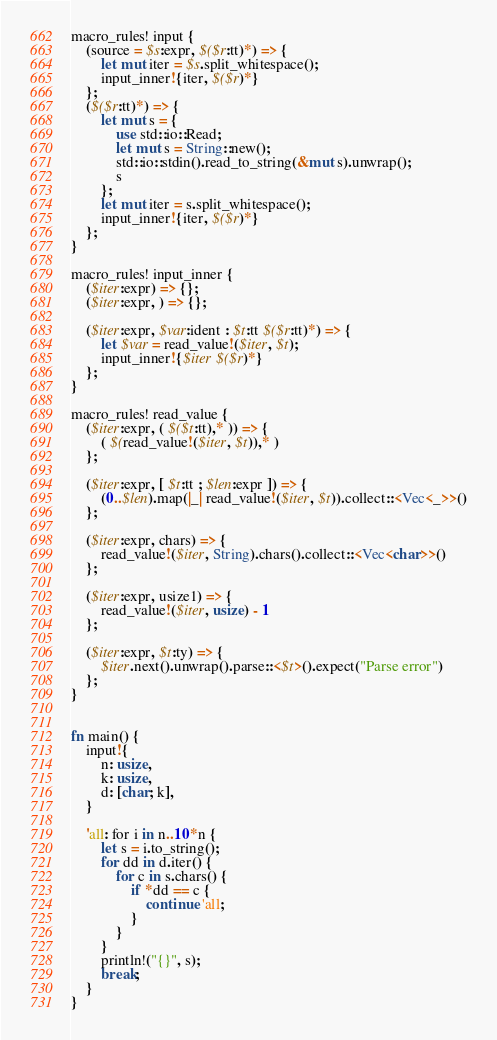Convert code to text. <code><loc_0><loc_0><loc_500><loc_500><_Rust_>macro_rules! input {
    (source = $s:expr, $($r:tt)*) => {
        let mut iter = $s.split_whitespace();
        input_inner!{iter, $($r)*}
    };
    ($($r:tt)*) => {
        let mut s = {
            use std::io::Read;
            let mut s = String::new();
            std::io::stdin().read_to_string(&mut s).unwrap();
            s
        };
        let mut iter = s.split_whitespace();
        input_inner!{iter, $($r)*}
    };
}

macro_rules! input_inner {
    ($iter:expr) => {};
    ($iter:expr, ) => {};

    ($iter:expr, $var:ident : $t:tt $($r:tt)*) => {
        let $var = read_value!($iter, $t);
        input_inner!{$iter $($r)*}
    };
}

macro_rules! read_value {
    ($iter:expr, ( $($t:tt),* )) => {
        ( $(read_value!($iter, $t)),* )
    };

    ($iter:expr, [ $t:tt ; $len:expr ]) => {
        (0..$len).map(|_| read_value!($iter, $t)).collect::<Vec<_>>()
    };

    ($iter:expr, chars) => {
        read_value!($iter, String).chars().collect::<Vec<char>>()
    };

    ($iter:expr, usize1) => {
        read_value!($iter, usize) - 1
    };

    ($iter:expr, $t:ty) => {
        $iter.next().unwrap().parse::<$t>().expect("Parse error")
    };
}


fn main() {
    input!{
        n: usize,
        k: usize,
        d: [char; k],
    }

    'all: for i in n..10*n {
        let s = i.to_string();
        for dd in d.iter() {
            for c in s.chars() {
                if *dd == c {
                    continue 'all;
                }
            }
        }
        println!("{}", s);
        break;
    }
}
</code> 